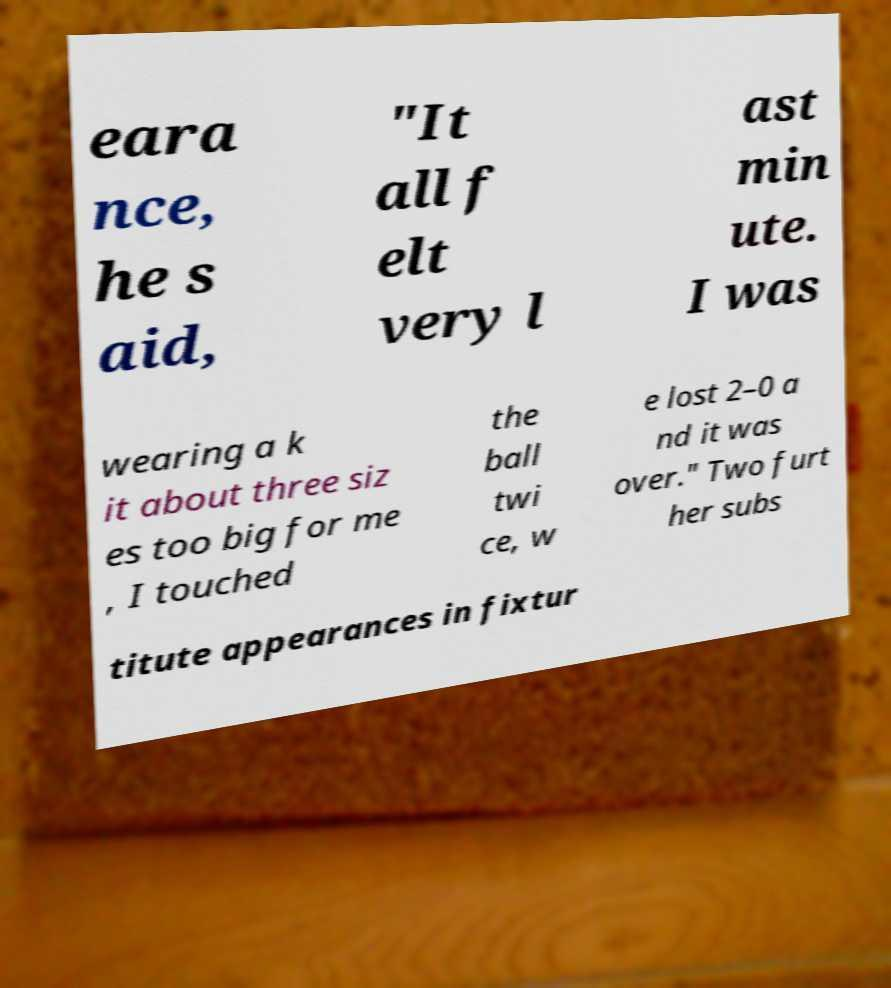Could you assist in decoding the text presented in this image and type it out clearly? eara nce, he s aid, "It all f elt very l ast min ute. I was wearing a k it about three siz es too big for me , I touched the ball twi ce, w e lost 2–0 a nd it was over." Two furt her subs titute appearances in fixtur 